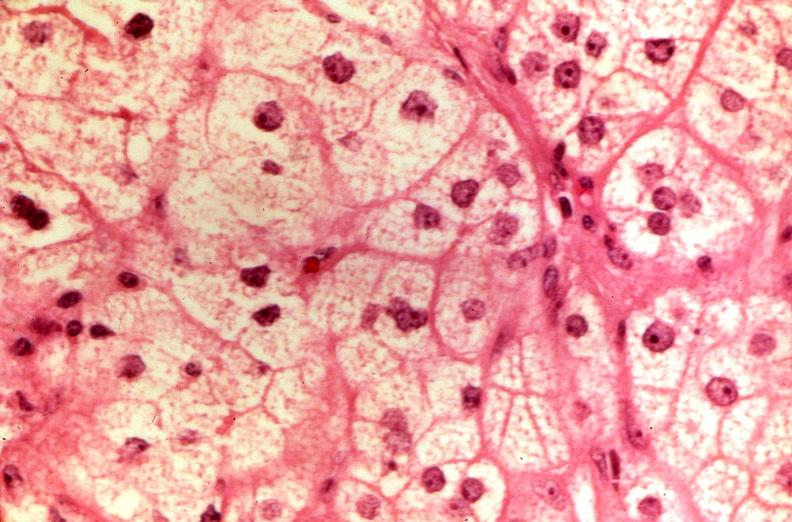where is this part in the figure?
Answer the question using a single word or phrase. Endocrine system 